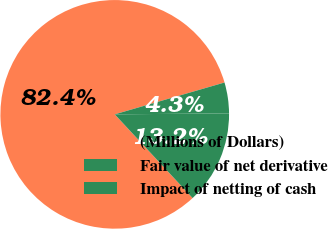Convert chart. <chart><loc_0><loc_0><loc_500><loc_500><pie_chart><fcel>(Millions of Dollars)<fcel>Fair value of net derivative<fcel>Impact of netting of cash<nl><fcel>82.43%<fcel>4.35%<fcel>13.22%<nl></chart> 